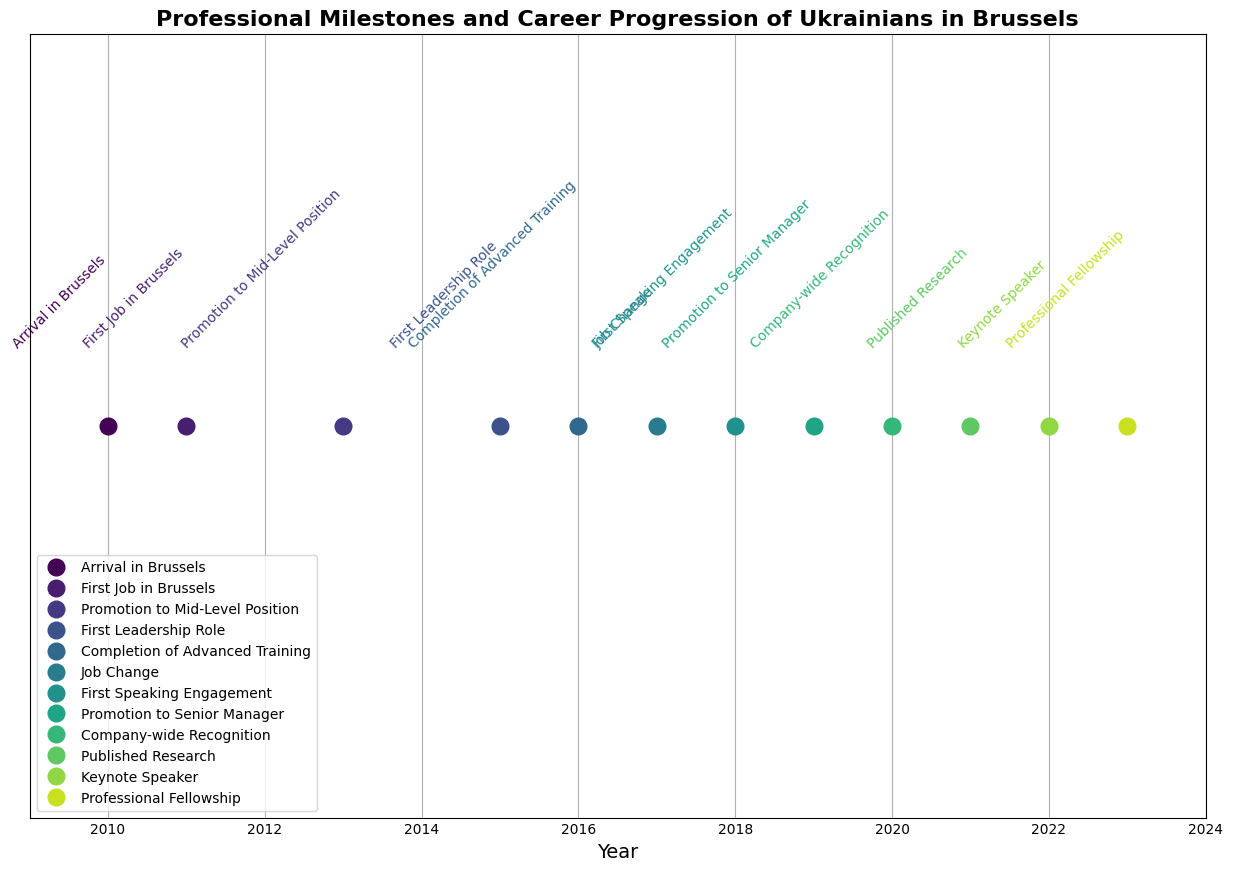What is the first professional milestone in the timeline, and in which year was it achieved? The first professional milestone is "Arrival in Brussels," achieved in the year 2010, as shown at the leftmost position on the timeline.
Answer: Arrival in Brussels, 2010 How many years after arriving in Brussels did the individual receive company-wide recognition? The individual arrived in Brussels in 2010 and received company-wide recognition in 2020. The difference in years is 2020 - 2010 = 10 years.
Answer: 10 years Which milestone occurred directly after the individual completed advanced training in 2016? The milestone directly after completing advanced training in 2016 is "Job Change" in 2017, which is the next event on the timeline.
Answer: Job Change, 2017 What is the average duration between consecutive milestones? Total years covered by the milestones are from 2010 to 2023, which is 13 years. There are 13 milestones, leading to 12 intervals. The average duration is therefore 13 / 12 ≈ 1.083 years.
Answer: ≈ 1.083 years Comparing the "First Leadership Role" and "Senior Manager Promotion" milestones, how many years apart are they? The "First Leadership Role" was in 2015, and the "Senior Manager Promotion" was in 2019. The difference is 2019 - 2015 = 4 years.
Answer: 4 years Which milestone is shown with the highest marker frequency around the year 2021? The highest marker frequency around the year 2021 corresponds to the milestone "Published Research."
Answer: Published Research How many years after the first job in Brussels did the individual switch to a managerial role at a different multinational firm? The first job in Brussels was in 2011, and the job switch to a managerial role was in 2017. The difference in years is 2017 - 2011 = 6 years.
Answer: 6 years What color represents the milestone "First Speaking Engagement" and how is it visually distinguished on the timeline? The milestone "First Speaking Engagement" is represented in a specific color along the green spectrum. It is visually distinguished by the specific text label "First Speaking Engagement" and the marker position at year 2018.
Answer: Green, 2018 What is the total number of milestones achieved between 2015 and 2020? The milestones achieved between 2015 and 2020 include "First Leadership Role" (2015), "Completion of Advanced Training" (2016), "Job Change" (2017), "First Speaking Engagement" (2018), and "Promotion to Senior Manager" (2019), and "Company-wide Recognition" (2020). Counting these gives 6 milestones.
Answer: 6 milestones What milestone occurred in the same year as the completion of the professional certification in data science? The milestone in the same year (2016) as the completion of the professional certification in data science is "Completion of Advanced Training."
Answer: Completion of Advanced Training, 2016 